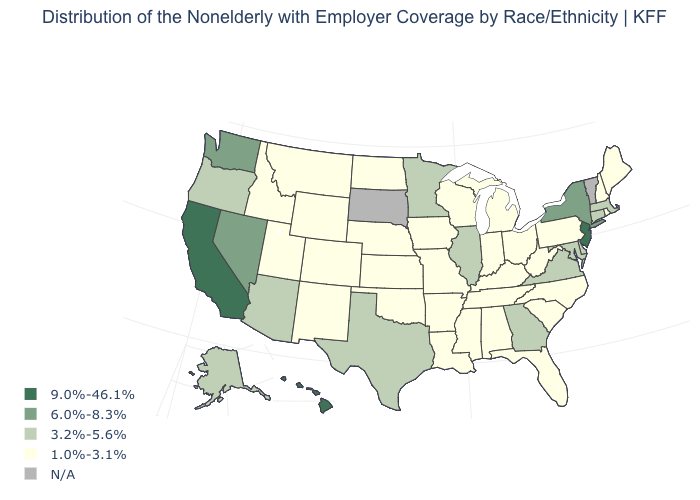Name the states that have a value in the range 3.2%-5.6%?
Short answer required. Alaska, Arizona, Connecticut, Delaware, Georgia, Illinois, Maryland, Massachusetts, Minnesota, Oregon, Texas, Virginia. What is the value of Colorado?
Write a very short answer. 1.0%-3.1%. Name the states that have a value in the range 1.0%-3.1%?
Give a very brief answer. Alabama, Arkansas, Colorado, Florida, Idaho, Indiana, Iowa, Kansas, Kentucky, Louisiana, Maine, Michigan, Mississippi, Missouri, Montana, Nebraska, New Hampshire, New Mexico, North Carolina, North Dakota, Ohio, Oklahoma, Pennsylvania, Rhode Island, South Carolina, Tennessee, Utah, West Virginia, Wisconsin, Wyoming. What is the value of Nevada?
Write a very short answer. 6.0%-8.3%. Name the states that have a value in the range 3.2%-5.6%?
Answer briefly. Alaska, Arizona, Connecticut, Delaware, Georgia, Illinois, Maryland, Massachusetts, Minnesota, Oregon, Texas, Virginia. Does the map have missing data?
Answer briefly. Yes. What is the highest value in the South ?
Concise answer only. 3.2%-5.6%. Which states hav the highest value in the Northeast?
Answer briefly. New Jersey. Does the first symbol in the legend represent the smallest category?
Give a very brief answer. No. Which states hav the highest value in the MidWest?
Quick response, please. Illinois, Minnesota. Is the legend a continuous bar?
Answer briefly. No. What is the lowest value in states that border Colorado?
Short answer required. 1.0%-3.1%. What is the highest value in states that border Texas?
Answer briefly. 1.0%-3.1%. Name the states that have a value in the range 1.0%-3.1%?
Write a very short answer. Alabama, Arkansas, Colorado, Florida, Idaho, Indiana, Iowa, Kansas, Kentucky, Louisiana, Maine, Michigan, Mississippi, Missouri, Montana, Nebraska, New Hampshire, New Mexico, North Carolina, North Dakota, Ohio, Oklahoma, Pennsylvania, Rhode Island, South Carolina, Tennessee, Utah, West Virginia, Wisconsin, Wyoming. What is the lowest value in states that border Kansas?
Answer briefly. 1.0%-3.1%. 